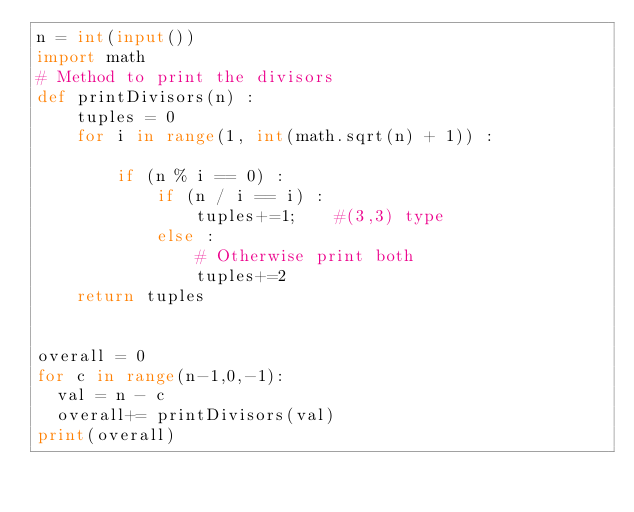Convert code to text. <code><loc_0><loc_0><loc_500><loc_500><_Python_>n = int(input())
import math
# Method to print the divisors 
def printDivisors(n) : 
    tuples = 0
    for i in range(1, int(math.sqrt(n) + 1)) : 
          
        if (n % i == 0) : 
            if (n / i == i) : 
                tuples+=1;    #(3,3) type
            else : 
                # Otherwise print both 
                tuples+=2
    return tuples
          

overall = 0  
for c in range(n-1,0,-1):
  val = n - c
  overall+= printDivisors(val)
print(overall)
  
  
</code> 